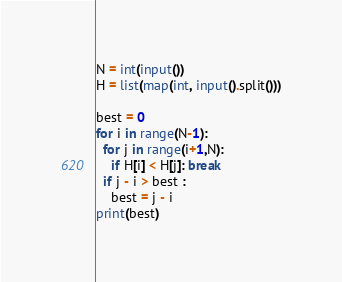Convert code to text. <code><loc_0><loc_0><loc_500><loc_500><_Python_>N = int(input())
H = list(map(int, input().split()))

best = 0
for i in range(N-1):
  for j in range(i+1,N):
    if H[i] < H[j]: break
  if j - i > best :
    best = j - i
print(best)</code> 